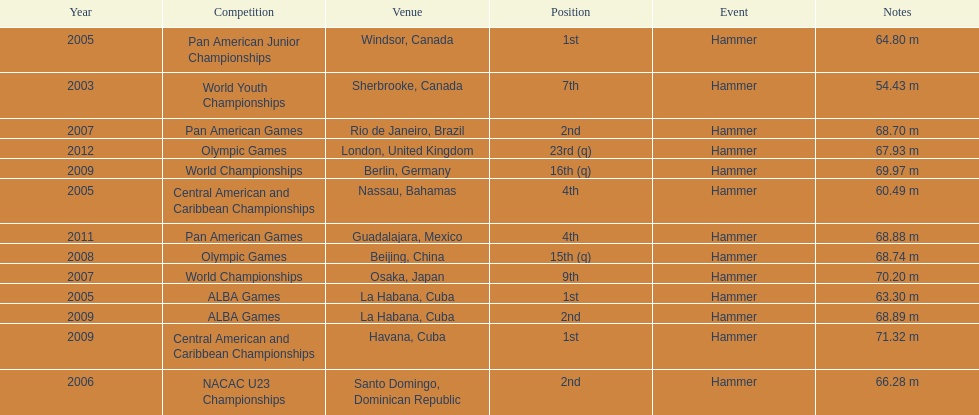Does arasay thondike have more/less than 4 1st place tournament finishes? Less. 